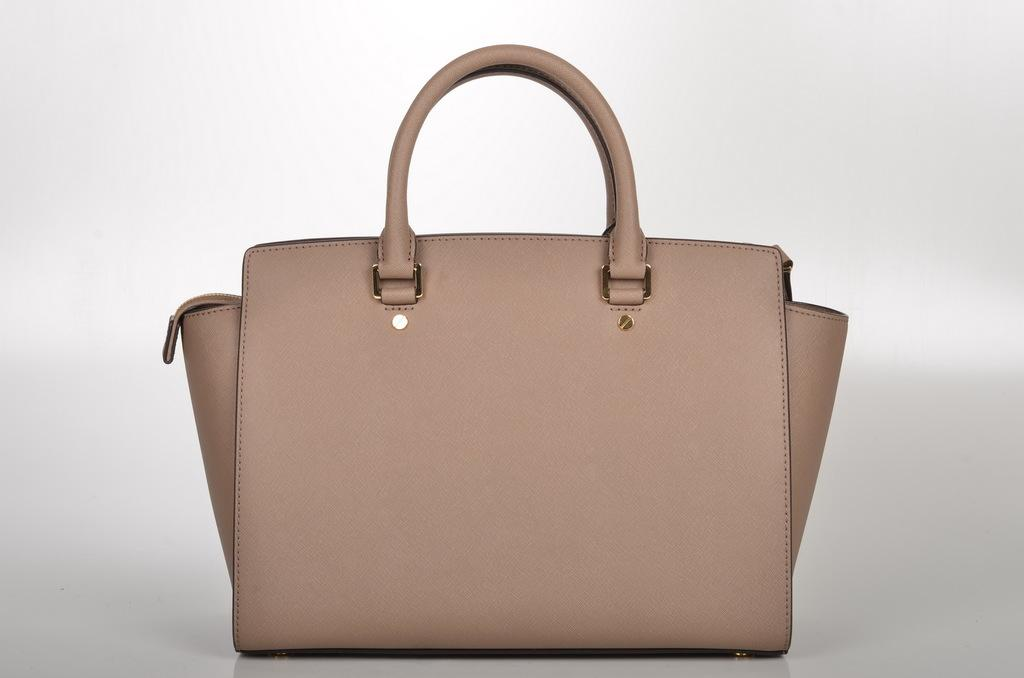What type of bag is visible in the image? There is a brown bag with a handle in the image. What color is the background of the image? The background of the image is white. What type of frame is surrounding the cloth in the image? There is no frame or cloth present in the image; it only features a brown bag with a handle against a white background. 